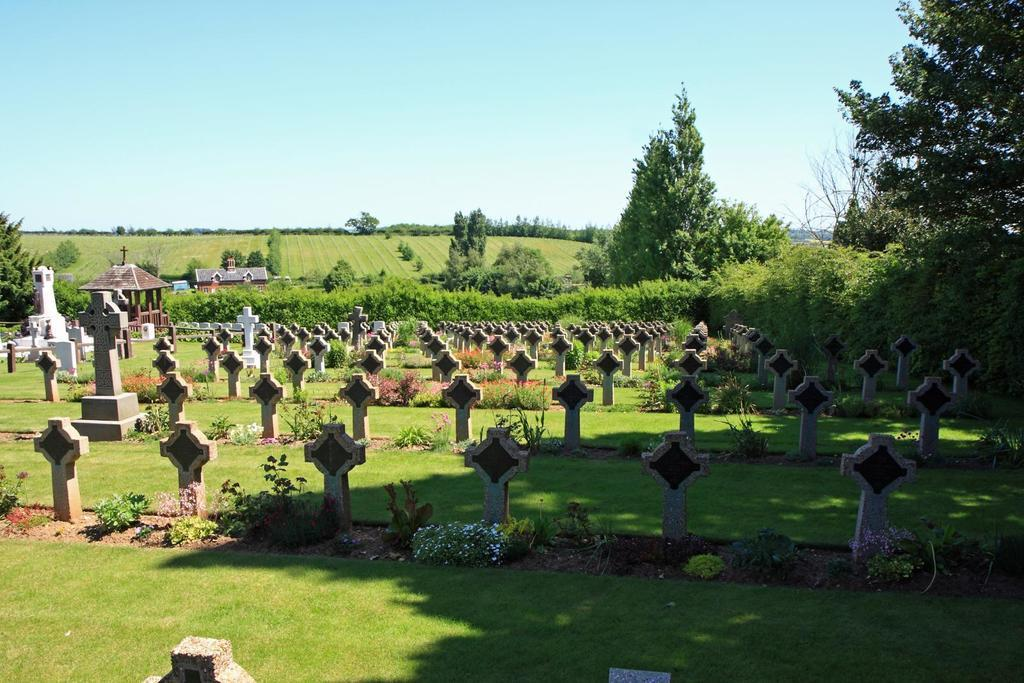What is the main subject of the image? The main subject of the image is a graveyard. Can you describe the graveyard in the image? The graveyard has many stones. What can be seen in the background of the image? There are trees and a green farm visible in the background of the image. Is there a girl playing with a ball in the image? No, there is no girl or ball present in the image. The image features a graveyard with many stones and a background that includes trees and a green farm. 